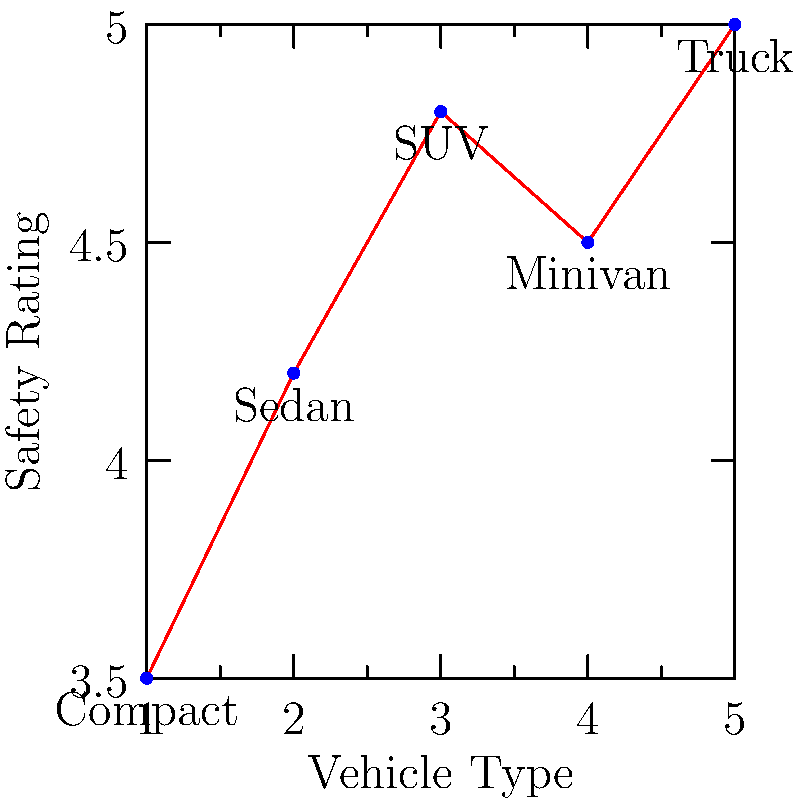Based on the scatter plot showing safety ratings for different vehicle types, which category demonstrates the highest safety rating, and what implications might this have for first-time car buyers concerned about safety? To answer this question, we need to analyze the scatter plot:

1. Identify the vehicle types and their corresponding safety ratings:
   - Compact: 3.5
   - Sedan: 4.2
   - SUV: 4.8
   - Minivan: 4.5
   - Truck: 5.0

2. Determine the highest safety rating:
   The truck category has the highest safety rating at 5.0.

3. Consider implications for first-time car buyers:
   a) Trucks offer the highest safety rating, which could be appealing to safety-conscious buyers.
   b) However, trucks may not be practical for all first-time buyers due to size, fuel efficiency, and driving experience required.
   c) SUVs and minivans also show high safety ratings (4.8 and 4.5 respectively), offering a balance between safety and practicality.
   d) Sedans have a moderate safety rating (4.2), which might be a good compromise for first-time buyers considering factors like cost and ease of driving.
   e) Compact cars have the lowest safety rating (3.5), which might be a concern for buyers prioritizing safety.

4. Recommendation for first-time buyers:
   Encourage consideration of SUVs or minivans as they offer high safety ratings while being more practical for everyday use compared to trucks. Emphasize the importance of balancing safety with other factors such as budget, fuel efficiency, and intended use of the vehicle.
Answer: Trucks have the highest safety rating, but SUVs or minivans may be more practical choices for first-time buyers seeking a balance of safety and usability. 